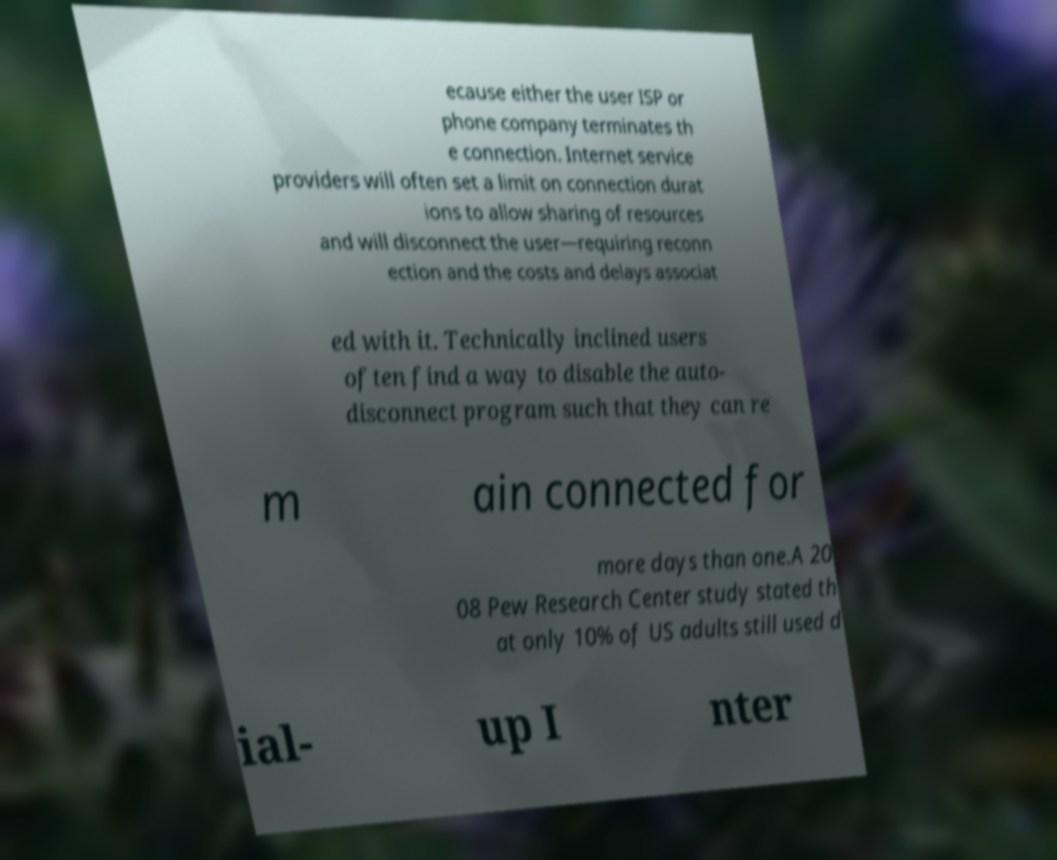What messages or text are displayed in this image? I need them in a readable, typed format. ecause either the user ISP or phone company terminates th e connection. Internet service providers will often set a limit on connection durat ions to allow sharing of resources and will disconnect the user—requiring reconn ection and the costs and delays associat ed with it. Technically inclined users often find a way to disable the auto- disconnect program such that they can re m ain connected for more days than one.A 20 08 Pew Research Center study stated th at only 10% of US adults still used d ial- up I nter 